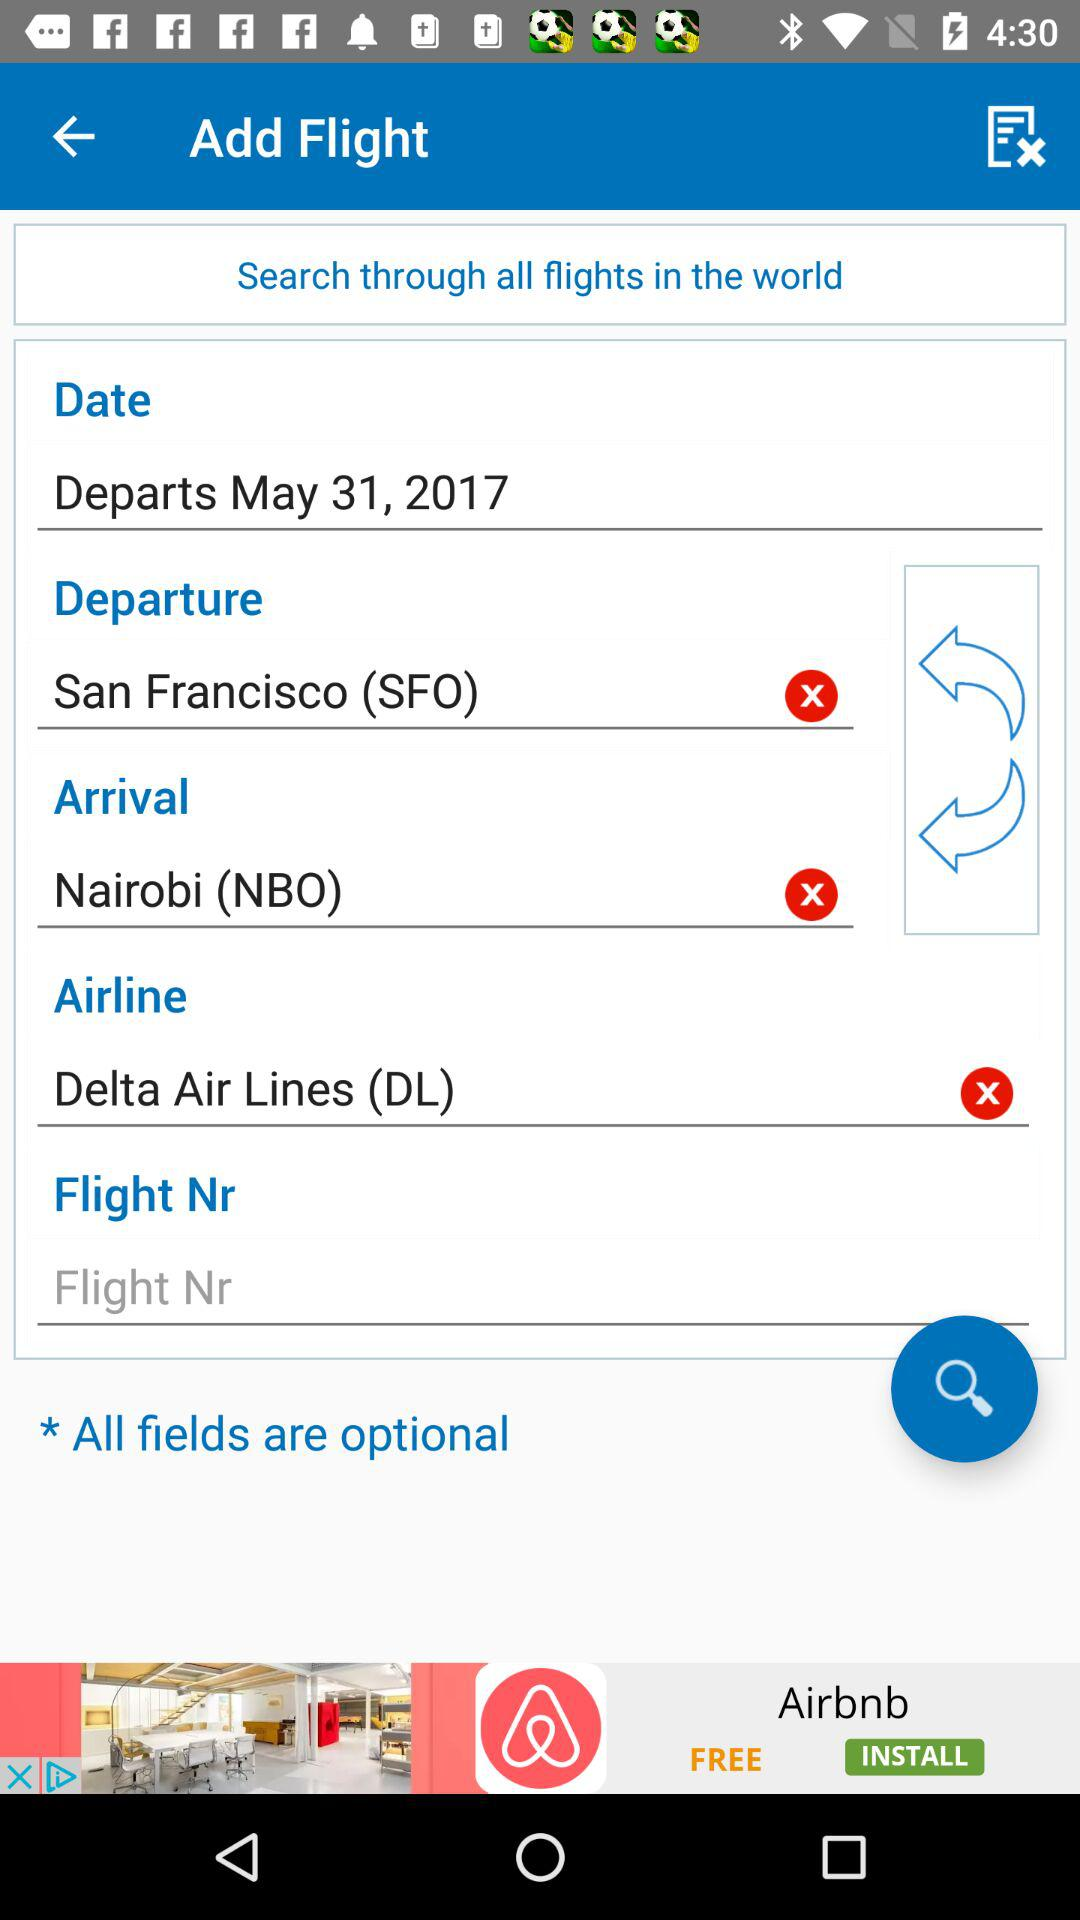What is the name of the airline? The name of the airline is "Delta Air Lines". 